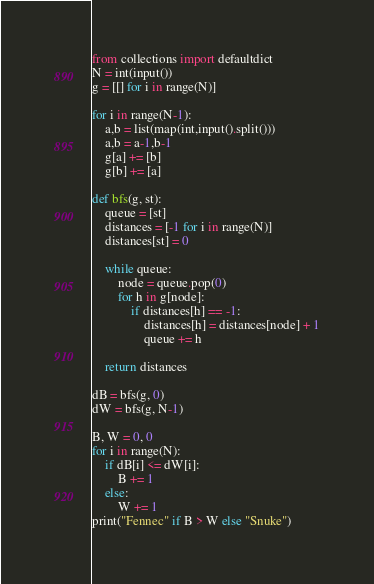<code> <loc_0><loc_0><loc_500><loc_500><_Python_>from collections import defaultdict
N = int(input())
g = [[] for i in range(N)]
 
for i in range(N-1):
    a,b = list(map(int,input().split()))
    a,b = a-1,b-1
    g[a] += [b]
    g[b] += [a]
    
def bfs(g, st):
    queue = [st]
    distances = [-1 for i in range(N)]
    distances[st] = 0
    
    while queue:
        node = queue.pop(0)
        for h in g[node]:
            if distances[h] == -1:
                distances[h] = distances[node] + 1
                queue += h
 
    return distances
 
dB = bfs(g, 0)
dW = bfs(g, N-1)
 
B, W = 0, 0
for i in range(N):
    if dB[i] <= dW[i]:
        B += 1
    else:
        W += 1
print("Fennec" if B > W else "Snuke")</code> 